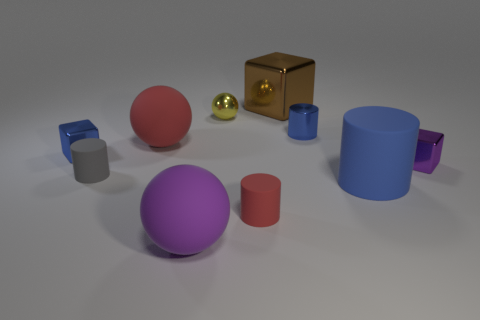What is the material of the big ball behind the tiny blue thing that is left of the tiny gray thing?
Your answer should be compact. Rubber. Are there fewer small yellow metallic objects that are to the right of the small yellow metallic thing than yellow metal balls that are left of the tiny blue block?
Make the answer very short. No. What is the material of the other cylinder that is the same color as the metallic cylinder?
Offer a terse response. Rubber. Is there anything else that has the same shape as the big brown object?
Make the answer very short. Yes. What is the material of the ball that is in front of the purple cube?
Keep it short and to the point. Rubber. Is there anything else that has the same size as the purple matte object?
Provide a succinct answer. Yes. Are there any big red rubber spheres left of the big brown metallic object?
Provide a succinct answer. Yes. What shape is the big metallic object?
Offer a terse response. Cube. How many objects are either big objects that are on the right side of the big brown shiny object or small metal cubes?
Keep it short and to the point. 3. What number of other things are the same color as the large cylinder?
Provide a short and direct response. 2. 